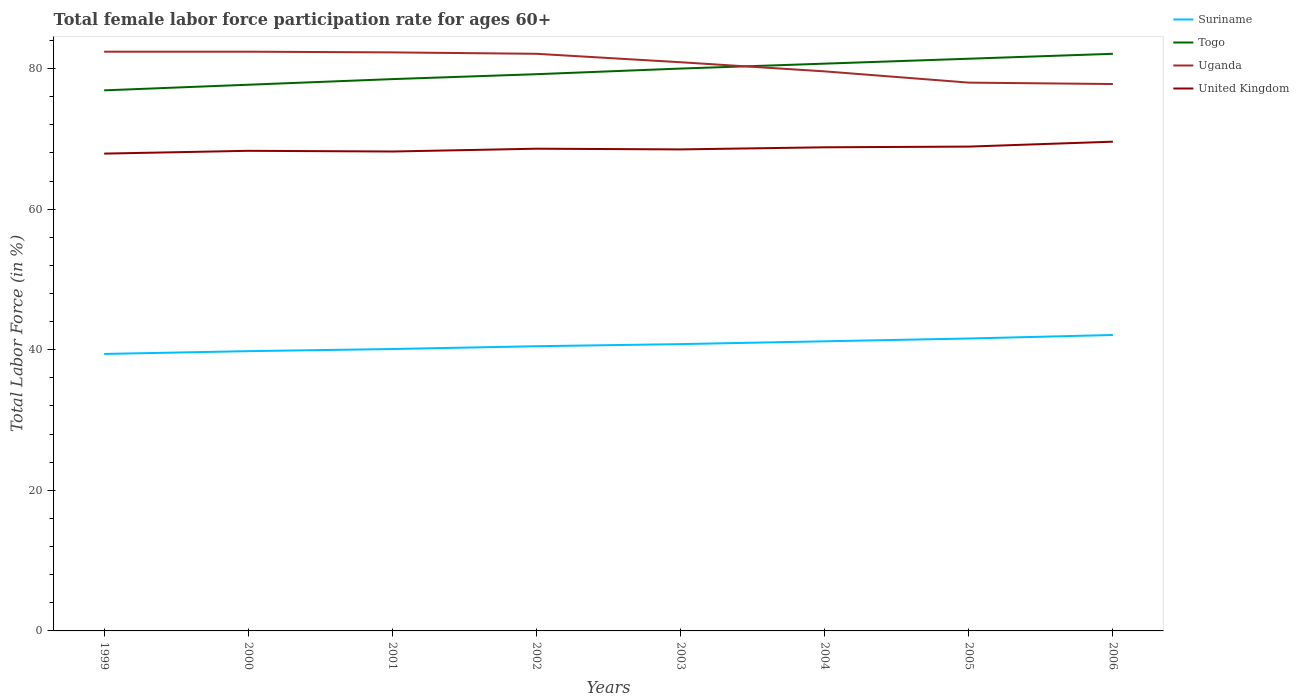How many different coloured lines are there?
Provide a short and direct response. 4. Across all years, what is the maximum female labor force participation rate in Uganda?
Give a very brief answer. 77.8. In which year was the female labor force participation rate in Suriname maximum?
Offer a terse response. 1999. What is the difference between the highest and the second highest female labor force participation rate in United Kingdom?
Keep it short and to the point. 1.7. Is the female labor force participation rate in Togo strictly greater than the female labor force participation rate in Suriname over the years?
Your response must be concise. No. Are the values on the major ticks of Y-axis written in scientific E-notation?
Offer a terse response. No. How are the legend labels stacked?
Offer a very short reply. Vertical. What is the title of the graph?
Offer a very short reply. Total female labor force participation rate for ages 60+. Does "Togo" appear as one of the legend labels in the graph?
Your answer should be compact. Yes. What is the Total Labor Force (in %) in Suriname in 1999?
Provide a succinct answer. 39.4. What is the Total Labor Force (in %) of Togo in 1999?
Provide a succinct answer. 76.9. What is the Total Labor Force (in %) in Uganda in 1999?
Provide a short and direct response. 82.4. What is the Total Labor Force (in %) of United Kingdom in 1999?
Keep it short and to the point. 67.9. What is the Total Labor Force (in %) of Suriname in 2000?
Your answer should be very brief. 39.8. What is the Total Labor Force (in %) in Togo in 2000?
Provide a short and direct response. 77.7. What is the Total Labor Force (in %) in Uganda in 2000?
Provide a short and direct response. 82.4. What is the Total Labor Force (in %) in United Kingdom in 2000?
Ensure brevity in your answer.  68.3. What is the Total Labor Force (in %) in Suriname in 2001?
Your response must be concise. 40.1. What is the Total Labor Force (in %) in Togo in 2001?
Give a very brief answer. 78.5. What is the Total Labor Force (in %) of Uganda in 2001?
Offer a very short reply. 82.3. What is the Total Labor Force (in %) of United Kingdom in 2001?
Offer a very short reply. 68.2. What is the Total Labor Force (in %) in Suriname in 2002?
Your response must be concise. 40.5. What is the Total Labor Force (in %) of Togo in 2002?
Your response must be concise. 79.2. What is the Total Labor Force (in %) in Uganda in 2002?
Provide a succinct answer. 82.1. What is the Total Labor Force (in %) of United Kingdom in 2002?
Give a very brief answer. 68.6. What is the Total Labor Force (in %) of Suriname in 2003?
Offer a terse response. 40.8. What is the Total Labor Force (in %) in Uganda in 2003?
Give a very brief answer. 80.9. What is the Total Labor Force (in %) in United Kingdom in 2003?
Offer a very short reply. 68.5. What is the Total Labor Force (in %) in Suriname in 2004?
Your response must be concise. 41.2. What is the Total Labor Force (in %) in Togo in 2004?
Keep it short and to the point. 80.7. What is the Total Labor Force (in %) of Uganda in 2004?
Give a very brief answer. 79.6. What is the Total Labor Force (in %) in United Kingdom in 2004?
Your answer should be very brief. 68.8. What is the Total Labor Force (in %) in Suriname in 2005?
Your answer should be compact. 41.6. What is the Total Labor Force (in %) in Togo in 2005?
Your response must be concise. 81.4. What is the Total Labor Force (in %) in Uganda in 2005?
Your answer should be very brief. 78. What is the Total Labor Force (in %) of United Kingdom in 2005?
Ensure brevity in your answer.  68.9. What is the Total Labor Force (in %) in Suriname in 2006?
Offer a very short reply. 42.1. What is the Total Labor Force (in %) of Togo in 2006?
Give a very brief answer. 82.1. What is the Total Labor Force (in %) in Uganda in 2006?
Provide a succinct answer. 77.8. What is the Total Labor Force (in %) in United Kingdom in 2006?
Offer a terse response. 69.6. Across all years, what is the maximum Total Labor Force (in %) in Suriname?
Keep it short and to the point. 42.1. Across all years, what is the maximum Total Labor Force (in %) in Togo?
Your answer should be compact. 82.1. Across all years, what is the maximum Total Labor Force (in %) of Uganda?
Make the answer very short. 82.4. Across all years, what is the maximum Total Labor Force (in %) in United Kingdom?
Offer a very short reply. 69.6. Across all years, what is the minimum Total Labor Force (in %) of Suriname?
Provide a short and direct response. 39.4. Across all years, what is the minimum Total Labor Force (in %) of Togo?
Offer a very short reply. 76.9. Across all years, what is the minimum Total Labor Force (in %) of Uganda?
Offer a terse response. 77.8. Across all years, what is the minimum Total Labor Force (in %) of United Kingdom?
Your response must be concise. 67.9. What is the total Total Labor Force (in %) in Suriname in the graph?
Make the answer very short. 325.5. What is the total Total Labor Force (in %) in Togo in the graph?
Provide a short and direct response. 636.5. What is the total Total Labor Force (in %) in Uganda in the graph?
Your response must be concise. 645.5. What is the total Total Labor Force (in %) in United Kingdom in the graph?
Keep it short and to the point. 548.8. What is the difference between the Total Labor Force (in %) in Suriname in 1999 and that in 2000?
Give a very brief answer. -0.4. What is the difference between the Total Labor Force (in %) in Suriname in 1999 and that in 2001?
Offer a terse response. -0.7. What is the difference between the Total Labor Force (in %) of Togo in 1999 and that in 2001?
Provide a succinct answer. -1.6. What is the difference between the Total Labor Force (in %) in Uganda in 1999 and that in 2001?
Offer a very short reply. 0.1. What is the difference between the Total Labor Force (in %) in United Kingdom in 1999 and that in 2001?
Your answer should be compact. -0.3. What is the difference between the Total Labor Force (in %) of Suriname in 1999 and that in 2002?
Provide a short and direct response. -1.1. What is the difference between the Total Labor Force (in %) in Togo in 1999 and that in 2002?
Offer a terse response. -2.3. What is the difference between the Total Labor Force (in %) in Uganda in 1999 and that in 2002?
Your answer should be compact. 0.3. What is the difference between the Total Labor Force (in %) of Suriname in 1999 and that in 2003?
Provide a succinct answer. -1.4. What is the difference between the Total Labor Force (in %) in Uganda in 1999 and that in 2003?
Ensure brevity in your answer.  1.5. What is the difference between the Total Labor Force (in %) in United Kingdom in 1999 and that in 2003?
Your answer should be compact. -0.6. What is the difference between the Total Labor Force (in %) in Uganda in 1999 and that in 2004?
Offer a very short reply. 2.8. What is the difference between the Total Labor Force (in %) in Suriname in 1999 and that in 2005?
Give a very brief answer. -2.2. What is the difference between the Total Labor Force (in %) in Uganda in 1999 and that in 2005?
Offer a very short reply. 4.4. What is the difference between the Total Labor Force (in %) in Suriname in 1999 and that in 2006?
Your response must be concise. -2.7. What is the difference between the Total Labor Force (in %) in United Kingdom in 2000 and that in 2001?
Keep it short and to the point. 0.1. What is the difference between the Total Labor Force (in %) in Uganda in 2000 and that in 2002?
Offer a very short reply. 0.3. What is the difference between the Total Labor Force (in %) in United Kingdom in 2000 and that in 2002?
Make the answer very short. -0.3. What is the difference between the Total Labor Force (in %) in Togo in 2000 and that in 2003?
Offer a terse response. -2.3. What is the difference between the Total Labor Force (in %) of Uganda in 2000 and that in 2003?
Provide a short and direct response. 1.5. What is the difference between the Total Labor Force (in %) of Suriname in 2000 and that in 2004?
Your response must be concise. -1.4. What is the difference between the Total Labor Force (in %) in United Kingdom in 2000 and that in 2004?
Your answer should be very brief. -0.5. What is the difference between the Total Labor Force (in %) in Togo in 2000 and that in 2005?
Make the answer very short. -3.7. What is the difference between the Total Labor Force (in %) in Uganda in 2000 and that in 2005?
Ensure brevity in your answer.  4.4. What is the difference between the Total Labor Force (in %) in United Kingdom in 2000 and that in 2005?
Your response must be concise. -0.6. What is the difference between the Total Labor Force (in %) in Suriname in 2000 and that in 2006?
Make the answer very short. -2.3. What is the difference between the Total Labor Force (in %) in Uganda in 2000 and that in 2006?
Keep it short and to the point. 4.6. What is the difference between the Total Labor Force (in %) in Suriname in 2001 and that in 2002?
Make the answer very short. -0.4. What is the difference between the Total Labor Force (in %) of Togo in 2001 and that in 2002?
Ensure brevity in your answer.  -0.7. What is the difference between the Total Labor Force (in %) in Uganda in 2001 and that in 2002?
Provide a short and direct response. 0.2. What is the difference between the Total Labor Force (in %) of Suriname in 2001 and that in 2003?
Make the answer very short. -0.7. What is the difference between the Total Labor Force (in %) in Uganda in 2001 and that in 2003?
Make the answer very short. 1.4. What is the difference between the Total Labor Force (in %) of United Kingdom in 2001 and that in 2003?
Ensure brevity in your answer.  -0.3. What is the difference between the Total Labor Force (in %) of Togo in 2001 and that in 2005?
Your answer should be compact. -2.9. What is the difference between the Total Labor Force (in %) in Suriname in 2001 and that in 2006?
Provide a short and direct response. -2. What is the difference between the Total Labor Force (in %) of Uganda in 2001 and that in 2006?
Provide a succinct answer. 4.5. What is the difference between the Total Labor Force (in %) in United Kingdom in 2001 and that in 2006?
Offer a terse response. -1.4. What is the difference between the Total Labor Force (in %) in Suriname in 2002 and that in 2003?
Your response must be concise. -0.3. What is the difference between the Total Labor Force (in %) in United Kingdom in 2002 and that in 2003?
Provide a short and direct response. 0.1. What is the difference between the Total Labor Force (in %) of Suriname in 2002 and that in 2004?
Ensure brevity in your answer.  -0.7. What is the difference between the Total Labor Force (in %) of Togo in 2002 and that in 2004?
Ensure brevity in your answer.  -1.5. What is the difference between the Total Labor Force (in %) in Suriname in 2002 and that in 2005?
Make the answer very short. -1.1. What is the difference between the Total Labor Force (in %) of Togo in 2002 and that in 2005?
Keep it short and to the point. -2.2. What is the difference between the Total Labor Force (in %) in Suriname in 2002 and that in 2006?
Give a very brief answer. -1.6. What is the difference between the Total Labor Force (in %) of Togo in 2002 and that in 2006?
Ensure brevity in your answer.  -2.9. What is the difference between the Total Labor Force (in %) in Uganda in 2002 and that in 2006?
Offer a very short reply. 4.3. What is the difference between the Total Labor Force (in %) in Suriname in 2003 and that in 2004?
Your answer should be very brief. -0.4. What is the difference between the Total Labor Force (in %) in Togo in 2003 and that in 2004?
Your answer should be compact. -0.7. What is the difference between the Total Labor Force (in %) of United Kingdom in 2003 and that in 2005?
Provide a succinct answer. -0.4. What is the difference between the Total Labor Force (in %) of Togo in 2003 and that in 2006?
Provide a short and direct response. -2.1. What is the difference between the Total Labor Force (in %) in Uganda in 2003 and that in 2006?
Provide a succinct answer. 3.1. What is the difference between the Total Labor Force (in %) in United Kingdom in 2003 and that in 2006?
Give a very brief answer. -1.1. What is the difference between the Total Labor Force (in %) in Suriname in 2004 and that in 2005?
Provide a short and direct response. -0.4. What is the difference between the Total Labor Force (in %) of Togo in 2004 and that in 2005?
Your answer should be very brief. -0.7. What is the difference between the Total Labor Force (in %) in Uganda in 2004 and that in 2005?
Offer a terse response. 1.6. What is the difference between the Total Labor Force (in %) of Togo in 2004 and that in 2006?
Provide a short and direct response. -1.4. What is the difference between the Total Labor Force (in %) of Suriname in 2005 and that in 2006?
Give a very brief answer. -0.5. What is the difference between the Total Labor Force (in %) of Togo in 2005 and that in 2006?
Ensure brevity in your answer.  -0.7. What is the difference between the Total Labor Force (in %) in Uganda in 2005 and that in 2006?
Provide a short and direct response. 0.2. What is the difference between the Total Labor Force (in %) of Suriname in 1999 and the Total Labor Force (in %) of Togo in 2000?
Make the answer very short. -38.3. What is the difference between the Total Labor Force (in %) in Suriname in 1999 and the Total Labor Force (in %) in Uganda in 2000?
Your response must be concise. -43. What is the difference between the Total Labor Force (in %) of Suriname in 1999 and the Total Labor Force (in %) of United Kingdom in 2000?
Your answer should be very brief. -28.9. What is the difference between the Total Labor Force (in %) of Suriname in 1999 and the Total Labor Force (in %) of Togo in 2001?
Provide a succinct answer. -39.1. What is the difference between the Total Labor Force (in %) of Suriname in 1999 and the Total Labor Force (in %) of Uganda in 2001?
Provide a short and direct response. -42.9. What is the difference between the Total Labor Force (in %) in Suriname in 1999 and the Total Labor Force (in %) in United Kingdom in 2001?
Give a very brief answer. -28.8. What is the difference between the Total Labor Force (in %) in Togo in 1999 and the Total Labor Force (in %) in United Kingdom in 2001?
Give a very brief answer. 8.7. What is the difference between the Total Labor Force (in %) in Uganda in 1999 and the Total Labor Force (in %) in United Kingdom in 2001?
Your answer should be very brief. 14.2. What is the difference between the Total Labor Force (in %) in Suriname in 1999 and the Total Labor Force (in %) in Togo in 2002?
Provide a short and direct response. -39.8. What is the difference between the Total Labor Force (in %) in Suriname in 1999 and the Total Labor Force (in %) in Uganda in 2002?
Provide a short and direct response. -42.7. What is the difference between the Total Labor Force (in %) in Suriname in 1999 and the Total Labor Force (in %) in United Kingdom in 2002?
Your answer should be very brief. -29.2. What is the difference between the Total Labor Force (in %) of Uganda in 1999 and the Total Labor Force (in %) of United Kingdom in 2002?
Provide a succinct answer. 13.8. What is the difference between the Total Labor Force (in %) in Suriname in 1999 and the Total Labor Force (in %) in Togo in 2003?
Provide a short and direct response. -40.6. What is the difference between the Total Labor Force (in %) in Suriname in 1999 and the Total Labor Force (in %) in Uganda in 2003?
Offer a terse response. -41.5. What is the difference between the Total Labor Force (in %) of Suriname in 1999 and the Total Labor Force (in %) of United Kingdom in 2003?
Ensure brevity in your answer.  -29.1. What is the difference between the Total Labor Force (in %) in Togo in 1999 and the Total Labor Force (in %) in Uganda in 2003?
Your answer should be very brief. -4. What is the difference between the Total Labor Force (in %) in Togo in 1999 and the Total Labor Force (in %) in United Kingdom in 2003?
Offer a very short reply. 8.4. What is the difference between the Total Labor Force (in %) in Uganda in 1999 and the Total Labor Force (in %) in United Kingdom in 2003?
Offer a terse response. 13.9. What is the difference between the Total Labor Force (in %) of Suriname in 1999 and the Total Labor Force (in %) of Togo in 2004?
Ensure brevity in your answer.  -41.3. What is the difference between the Total Labor Force (in %) in Suriname in 1999 and the Total Labor Force (in %) in Uganda in 2004?
Your response must be concise. -40.2. What is the difference between the Total Labor Force (in %) of Suriname in 1999 and the Total Labor Force (in %) of United Kingdom in 2004?
Provide a short and direct response. -29.4. What is the difference between the Total Labor Force (in %) of Togo in 1999 and the Total Labor Force (in %) of Uganda in 2004?
Provide a short and direct response. -2.7. What is the difference between the Total Labor Force (in %) of Togo in 1999 and the Total Labor Force (in %) of United Kingdom in 2004?
Ensure brevity in your answer.  8.1. What is the difference between the Total Labor Force (in %) of Uganda in 1999 and the Total Labor Force (in %) of United Kingdom in 2004?
Provide a succinct answer. 13.6. What is the difference between the Total Labor Force (in %) in Suriname in 1999 and the Total Labor Force (in %) in Togo in 2005?
Your answer should be very brief. -42. What is the difference between the Total Labor Force (in %) of Suriname in 1999 and the Total Labor Force (in %) of Uganda in 2005?
Your response must be concise. -38.6. What is the difference between the Total Labor Force (in %) in Suriname in 1999 and the Total Labor Force (in %) in United Kingdom in 2005?
Provide a short and direct response. -29.5. What is the difference between the Total Labor Force (in %) of Togo in 1999 and the Total Labor Force (in %) of Uganda in 2005?
Ensure brevity in your answer.  -1.1. What is the difference between the Total Labor Force (in %) of Togo in 1999 and the Total Labor Force (in %) of United Kingdom in 2005?
Ensure brevity in your answer.  8. What is the difference between the Total Labor Force (in %) in Suriname in 1999 and the Total Labor Force (in %) in Togo in 2006?
Make the answer very short. -42.7. What is the difference between the Total Labor Force (in %) in Suriname in 1999 and the Total Labor Force (in %) in Uganda in 2006?
Keep it short and to the point. -38.4. What is the difference between the Total Labor Force (in %) of Suriname in 1999 and the Total Labor Force (in %) of United Kingdom in 2006?
Offer a terse response. -30.2. What is the difference between the Total Labor Force (in %) in Togo in 1999 and the Total Labor Force (in %) in United Kingdom in 2006?
Provide a succinct answer. 7.3. What is the difference between the Total Labor Force (in %) in Uganda in 1999 and the Total Labor Force (in %) in United Kingdom in 2006?
Your response must be concise. 12.8. What is the difference between the Total Labor Force (in %) of Suriname in 2000 and the Total Labor Force (in %) of Togo in 2001?
Offer a very short reply. -38.7. What is the difference between the Total Labor Force (in %) in Suriname in 2000 and the Total Labor Force (in %) in Uganda in 2001?
Your answer should be very brief. -42.5. What is the difference between the Total Labor Force (in %) in Suriname in 2000 and the Total Labor Force (in %) in United Kingdom in 2001?
Your answer should be very brief. -28.4. What is the difference between the Total Labor Force (in %) in Suriname in 2000 and the Total Labor Force (in %) in Togo in 2002?
Offer a very short reply. -39.4. What is the difference between the Total Labor Force (in %) of Suriname in 2000 and the Total Labor Force (in %) of Uganda in 2002?
Give a very brief answer. -42.3. What is the difference between the Total Labor Force (in %) of Suriname in 2000 and the Total Labor Force (in %) of United Kingdom in 2002?
Offer a terse response. -28.8. What is the difference between the Total Labor Force (in %) in Togo in 2000 and the Total Labor Force (in %) in Uganda in 2002?
Provide a short and direct response. -4.4. What is the difference between the Total Labor Force (in %) of Togo in 2000 and the Total Labor Force (in %) of United Kingdom in 2002?
Make the answer very short. 9.1. What is the difference between the Total Labor Force (in %) of Suriname in 2000 and the Total Labor Force (in %) of Togo in 2003?
Offer a very short reply. -40.2. What is the difference between the Total Labor Force (in %) in Suriname in 2000 and the Total Labor Force (in %) in Uganda in 2003?
Offer a very short reply. -41.1. What is the difference between the Total Labor Force (in %) in Suriname in 2000 and the Total Labor Force (in %) in United Kingdom in 2003?
Offer a terse response. -28.7. What is the difference between the Total Labor Force (in %) in Togo in 2000 and the Total Labor Force (in %) in United Kingdom in 2003?
Provide a short and direct response. 9.2. What is the difference between the Total Labor Force (in %) of Suriname in 2000 and the Total Labor Force (in %) of Togo in 2004?
Your answer should be very brief. -40.9. What is the difference between the Total Labor Force (in %) of Suriname in 2000 and the Total Labor Force (in %) of Uganda in 2004?
Your response must be concise. -39.8. What is the difference between the Total Labor Force (in %) of Togo in 2000 and the Total Labor Force (in %) of United Kingdom in 2004?
Your response must be concise. 8.9. What is the difference between the Total Labor Force (in %) in Uganda in 2000 and the Total Labor Force (in %) in United Kingdom in 2004?
Your answer should be compact. 13.6. What is the difference between the Total Labor Force (in %) in Suriname in 2000 and the Total Labor Force (in %) in Togo in 2005?
Your answer should be compact. -41.6. What is the difference between the Total Labor Force (in %) in Suriname in 2000 and the Total Labor Force (in %) in Uganda in 2005?
Provide a short and direct response. -38.2. What is the difference between the Total Labor Force (in %) in Suriname in 2000 and the Total Labor Force (in %) in United Kingdom in 2005?
Provide a succinct answer. -29.1. What is the difference between the Total Labor Force (in %) in Togo in 2000 and the Total Labor Force (in %) in Uganda in 2005?
Offer a terse response. -0.3. What is the difference between the Total Labor Force (in %) of Uganda in 2000 and the Total Labor Force (in %) of United Kingdom in 2005?
Your answer should be compact. 13.5. What is the difference between the Total Labor Force (in %) of Suriname in 2000 and the Total Labor Force (in %) of Togo in 2006?
Your answer should be compact. -42.3. What is the difference between the Total Labor Force (in %) in Suriname in 2000 and the Total Labor Force (in %) in Uganda in 2006?
Keep it short and to the point. -38. What is the difference between the Total Labor Force (in %) in Suriname in 2000 and the Total Labor Force (in %) in United Kingdom in 2006?
Your answer should be very brief. -29.8. What is the difference between the Total Labor Force (in %) of Togo in 2000 and the Total Labor Force (in %) of Uganda in 2006?
Offer a very short reply. -0.1. What is the difference between the Total Labor Force (in %) of Togo in 2000 and the Total Labor Force (in %) of United Kingdom in 2006?
Give a very brief answer. 8.1. What is the difference between the Total Labor Force (in %) in Uganda in 2000 and the Total Labor Force (in %) in United Kingdom in 2006?
Ensure brevity in your answer.  12.8. What is the difference between the Total Labor Force (in %) of Suriname in 2001 and the Total Labor Force (in %) of Togo in 2002?
Ensure brevity in your answer.  -39.1. What is the difference between the Total Labor Force (in %) in Suriname in 2001 and the Total Labor Force (in %) in Uganda in 2002?
Make the answer very short. -42. What is the difference between the Total Labor Force (in %) in Suriname in 2001 and the Total Labor Force (in %) in United Kingdom in 2002?
Your response must be concise. -28.5. What is the difference between the Total Labor Force (in %) in Togo in 2001 and the Total Labor Force (in %) in Uganda in 2002?
Ensure brevity in your answer.  -3.6. What is the difference between the Total Labor Force (in %) in Togo in 2001 and the Total Labor Force (in %) in United Kingdom in 2002?
Provide a succinct answer. 9.9. What is the difference between the Total Labor Force (in %) in Uganda in 2001 and the Total Labor Force (in %) in United Kingdom in 2002?
Make the answer very short. 13.7. What is the difference between the Total Labor Force (in %) of Suriname in 2001 and the Total Labor Force (in %) of Togo in 2003?
Your answer should be compact. -39.9. What is the difference between the Total Labor Force (in %) in Suriname in 2001 and the Total Labor Force (in %) in Uganda in 2003?
Make the answer very short. -40.8. What is the difference between the Total Labor Force (in %) of Suriname in 2001 and the Total Labor Force (in %) of United Kingdom in 2003?
Ensure brevity in your answer.  -28.4. What is the difference between the Total Labor Force (in %) in Togo in 2001 and the Total Labor Force (in %) in United Kingdom in 2003?
Your answer should be compact. 10. What is the difference between the Total Labor Force (in %) in Uganda in 2001 and the Total Labor Force (in %) in United Kingdom in 2003?
Your answer should be very brief. 13.8. What is the difference between the Total Labor Force (in %) in Suriname in 2001 and the Total Labor Force (in %) in Togo in 2004?
Offer a terse response. -40.6. What is the difference between the Total Labor Force (in %) in Suriname in 2001 and the Total Labor Force (in %) in Uganda in 2004?
Your response must be concise. -39.5. What is the difference between the Total Labor Force (in %) of Suriname in 2001 and the Total Labor Force (in %) of United Kingdom in 2004?
Your answer should be compact. -28.7. What is the difference between the Total Labor Force (in %) in Togo in 2001 and the Total Labor Force (in %) in Uganda in 2004?
Offer a terse response. -1.1. What is the difference between the Total Labor Force (in %) in Togo in 2001 and the Total Labor Force (in %) in United Kingdom in 2004?
Provide a short and direct response. 9.7. What is the difference between the Total Labor Force (in %) of Suriname in 2001 and the Total Labor Force (in %) of Togo in 2005?
Provide a succinct answer. -41.3. What is the difference between the Total Labor Force (in %) of Suriname in 2001 and the Total Labor Force (in %) of Uganda in 2005?
Give a very brief answer. -37.9. What is the difference between the Total Labor Force (in %) of Suriname in 2001 and the Total Labor Force (in %) of United Kingdom in 2005?
Ensure brevity in your answer.  -28.8. What is the difference between the Total Labor Force (in %) in Suriname in 2001 and the Total Labor Force (in %) in Togo in 2006?
Provide a short and direct response. -42. What is the difference between the Total Labor Force (in %) in Suriname in 2001 and the Total Labor Force (in %) in Uganda in 2006?
Offer a very short reply. -37.7. What is the difference between the Total Labor Force (in %) of Suriname in 2001 and the Total Labor Force (in %) of United Kingdom in 2006?
Provide a succinct answer. -29.5. What is the difference between the Total Labor Force (in %) in Togo in 2001 and the Total Labor Force (in %) in Uganda in 2006?
Provide a succinct answer. 0.7. What is the difference between the Total Labor Force (in %) in Suriname in 2002 and the Total Labor Force (in %) in Togo in 2003?
Offer a terse response. -39.5. What is the difference between the Total Labor Force (in %) of Suriname in 2002 and the Total Labor Force (in %) of Uganda in 2003?
Give a very brief answer. -40.4. What is the difference between the Total Labor Force (in %) of Suriname in 2002 and the Total Labor Force (in %) of Togo in 2004?
Offer a very short reply. -40.2. What is the difference between the Total Labor Force (in %) of Suriname in 2002 and the Total Labor Force (in %) of Uganda in 2004?
Make the answer very short. -39.1. What is the difference between the Total Labor Force (in %) of Suriname in 2002 and the Total Labor Force (in %) of United Kingdom in 2004?
Provide a short and direct response. -28.3. What is the difference between the Total Labor Force (in %) of Togo in 2002 and the Total Labor Force (in %) of Uganda in 2004?
Offer a terse response. -0.4. What is the difference between the Total Labor Force (in %) in Togo in 2002 and the Total Labor Force (in %) in United Kingdom in 2004?
Give a very brief answer. 10.4. What is the difference between the Total Labor Force (in %) of Suriname in 2002 and the Total Labor Force (in %) of Togo in 2005?
Your answer should be very brief. -40.9. What is the difference between the Total Labor Force (in %) of Suriname in 2002 and the Total Labor Force (in %) of Uganda in 2005?
Keep it short and to the point. -37.5. What is the difference between the Total Labor Force (in %) of Suriname in 2002 and the Total Labor Force (in %) of United Kingdom in 2005?
Keep it short and to the point. -28.4. What is the difference between the Total Labor Force (in %) in Togo in 2002 and the Total Labor Force (in %) in United Kingdom in 2005?
Offer a terse response. 10.3. What is the difference between the Total Labor Force (in %) in Uganda in 2002 and the Total Labor Force (in %) in United Kingdom in 2005?
Your answer should be very brief. 13.2. What is the difference between the Total Labor Force (in %) in Suriname in 2002 and the Total Labor Force (in %) in Togo in 2006?
Offer a terse response. -41.6. What is the difference between the Total Labor Force (in %) in Suriname in 2002 and the Total Labor Force (in %) in Uganda in 2006?
Make the answer very short. -37.3. What is the difference between the Total Labor Force (in %) in Suriname in 2002 and the Total Labor Force (in %) in United Kingdom in 2006?
Offer a very short reply. -29.1. What is the difference between the Total Labor Force (in %) of Togo in 2002 and the Total Labor Force (in %) of United Kingdom in 2006?
Your response must be concise. 9.6. What is the difference between the Total Labor Force (in %) in Uganda in 2002 and the Total Labor Force (in %) in United Kingdom in 2006?
Make the answer very short. 12.5. What is the difference between the Total Labor Force (in %) in Suriname in 2003 and the Total Labor Force (in %) in Togo in 2004?
Ensure brevity in your answer.  -39.9. What is the difference between the Total Labor Force (in %) in Suriname in 2003 and the Total Labor Force (in %) in Uganda in 2004?
Give a very brief answer. -38.8. What is the difference between the Total Labor Force (in %) in Togo in 2003 and the Total Labor Force (in %) in Uganda in 2004?
Make the answer very short. 0.4. What is the difference between the Total Labor Force (in %) in Togo in 2003 and the Total Labor Force (in %) in United Kingdom in 2004?
Your answer should be very brief. 11.2. What is the difference between the Total Labor Force (in %) in Uganda in 2003 and the Total Labor Force (in %) in United Kingdom in 2004?
Your answer should be very brief. 12.1. What is the difference between the Total Labor Force (in %) in Suriname in 2003 and the Total Labor Force (in %) in Togo in 2005?
Provide a succinct answer. -40.6. What is the difference between the Total Labor Force (in %) of Suriname in 2003 and the Total Labor Force (in %) of Uganda in 2005?
Your answer should be compact. -37.2. What is the difference between the Total Labor Force (in %) in Suriname in 2003 and the Total Labor Force (in %) in United Kingdom in 2005?
Ensure brevity in your answer.  -28.1. What is the difference between the Total Labor Force (in %) in Togo in 2003 and the Total Labor Force (in %) in Uganda in 2005?
Your answer should be compact. 2. What is the difference between the Total Labor Force (in %) in Togo in 2003 and the Total Labor Force (in %) in United Kingdom in 2005?
Make the answer very short. 11.1. What is the difference between the Total Labor Force (in %) in Uganda in 2003 and the Total Labor Force (in %) in United Kingdom in 2005?
Provide a succinct answer. 12. What is the difference between the Total Labor Force (in %) in Suriname in 2003 and the Total Labor Force (in %) in Togo in 2006?
Offer a terse response. -41.3. What is the difference between the Total Labor Force (in %) in Suriname in 2003 and the Total Labor Force (in %) in Uganda in 2006?
Give a very brief answer. -37. What is the difference between the Total Labor Force (in %) of Suriname in 2003 and the Total Labor Force (in %) of United Kingdom in 2006?
Offer a terse response. -28.8. What is the difference between the Total Labor Force (in %) in Togo in 2003 and the Total Labor Force (in %) in United Kingdom in 2006?
Make the answer very short. 10.4. What is the difference between the Total Labor Force (in %) in Uganda in 2003 and the Total Labor Force (in %) in United Kingdom in 2006?
Offer a terse response. 11.3. What is the difference between the Total Labor Force (in %) of Suriname in 2004 and the Total Labor Force (in %) of Togo in 2005?
Ensure brevity in your answer.  -40.2. What is the difference between the Total Labor Force (in %) of Suriname in 2004 and the Total Labor Force (in %) of Uganda in 2005?
Provide a short and direct response. -36.8. What is the difference between the Total Labor Force (in %) in Suriname in 2004 and the Total Labor Force (in %) in United Kingdom in 2005?
Offer a very short reply. -27.7. What is the difference between the Total Labor Force (in %) of Uganda in 2004 and the Total Labor Force (in %) of United Kingdom in 2005?
Your answer should be very brief. 10.7. What is the difference between the Total Labor Force (in %) of Suriname in 2004 and the Total Labor Force (in %) of Togo in 2006?
Your answer should be very brief. -40.9. What is the difference between the Total Labor Force (in %) in Suriname in 2004 and the Total Labor Force (in %) in Uganda in 2006?
Give a very brief answer. -36.6. What is the difference between the Total Labor Force (in %) in Suriname in 2004 and the Total Labor Force (in %) in United Kingdom in 2006?
Your answer should be very brief. -28.4. What is the difference between the Total Labor Force (in %) of Togo in 2004 and the Total Labor Force (in %) of United Kingdom in 2006?
Your answer should be compact. 11.1. What is the difference between the Total Labor Force (in %) in Uganda in 2004 and the Total Labor Force (in %) in United Kingdom in 2006?
Your answer should be compact. 10. What is the difference between the Total Labor Force (in %) of Suriname in 2005 and the Total Labor Force (in %) of Togo in 2006?
Provide a succinct answer. -40.5. What is the difference between the Total Labor Force (in %) of Suriname in 2005 and the Total Labor Force (in %) of Uganda in 2006?
Provide a succinct answer. -36.2. What is the difference between the Total Labor Force (in %) in Togo in 2005 and the Total Labor Force (in %) in United Kingdom in 2006?
Make the answer very short. 11.8. What is the difference between the Total Labor Force (in %) of Uganda in 2005 and the Total Labor Force (in %) of United Kingdom in 2006?
Make the answer very short. 8.4. What is the average Total Labor Force (in %) of Suriname per year?
Your answer should be compact. 40.69. What is the average Total Labor Force (in %) in Togo per year?
Offer a terse response. 79.56. What is the average Total Labor Force (in %) of Uganda per year?
Your answer should be very brief. 80.69. What is the average Total Labor Force (in %) of United Kingdom per year?
Ensure brevity in your answer.  68.6. In the year 1999, what is the difference between the Total Labor Force (in %) in Suriname and Total Labor Force (in %) in Togo?
Provide a short and direct response. -37.5. In the year 1999, what is the difference between the Total Labor Force (in %) in Suriname and Total Labor Force (in %) in Uganda?
Keep it short and to the point. -43. In the year 1999, what is the difference between the Total Labor Force (in %) of Suriname and Total Labor Force (in %) of United Kingdom?
Your response must be concise. -28.5. In the year 2000, what is the difference between the Total Labor Force (in %) of Suriname and Total Labor Force (in %) of Togo?
Provide a succinct answer. -37.9. In the year 2000, what is the difference between the Total Labor Force (in %) in Suriname and Total Labor Force (in %) in Uganda?
Ensure brevity in your answer.  -42.6. In the year 2000, what is the difference between the Total Labor Force (in %) of Suriname and Total Labor Force (in %) of United Kingdom?
Provide a succinct answer. -28.5. In the year 2000, what is the difference between the Total Labor Force (in %) in Togo and Total Labor Force (in %) in Uganda?
Keep it short and to the point. -4.7. In the year 2001, what is the difference between the Total Labor Force (in %) in Suriname and Total Labor Force (in %) in Togo?
Offer a very short reply. -38.4. In the year 2001, what is the difference between the Total Labor Force (in %) in Suriname and Total Labor Force (in %) in Uganda?
Offer a very short reply. -42.2. In the year 2001, what is the difference between the Total Labor Force (in %) in Suriname and Total Labor Force (in %) in United Kingdom?
Your response must be concise. -28.1. In the year 2001, what is the difference between the Total Labor Force (in %) of Togo and Total Labor Force (in %) of Uganda?
Your response must be concise. -3.8. In the year 2001, what is the difference between the Total Labor Force (in %) of Uganda and Total Labor Force (in %) of United Kingdom?
Offer a very short reply. 14.1. In the year 2002, what is the difference between the Total Labor Force (in %) in Suriname and Total Labor Force (in %) in Togo?
Your answer should be compact. -38.7. In the year 2002, what is the difference between the Total Labor Force (in %) of Suriname and Total Labor Force (in %) of Uganda?
Provide a short and direct response. -41.6. In the year 2002, what is the difference between the Total Labor Force (in %) of Suriname and Total Labor Force (in %) of United Kingdom?
Make the answer very short. -28.1. In the year 2002, what is the difference between the Total Labor Force (in %) of Togo and Total Labor Force (in %) of Uganda?
Ensure brevity in your answer.  -2.9. In the year 2002, what is the difference between the Total Labor Force (in %) in Togo and Total Labor Force (in %) in United Kingdom?
Your answer should be very brief. 10.6. In the year 2002, what is the difference between the Total Labor Force (in %) in Uganda and Total Labor Force (in %) in United Kingdom?
Make the answer very short. 13.5. In the year 2003, what is the difference between the Total Labor Force (in %) of Suriname and Total Labor Force (in %) of Togo?
Your response must be concise. -39.2. In the year 2003, what is the difference between the Total Labor Force (in %) of Suriname and Total Labor Force (in %) of Uganda?
Your response must be concise. -40.1. In the year 2003, what is the difference between the Total Labor Force (in %) of Suriname and Total Labor Force (in %) of United Kingdom?
Your answer should be very brief. -27.7. In the year 2003, what is the difference between the Total Labor Force (in %) of Togo and Total Labor Force (in %) of United Kingdom?
Offer a very short reply. 11.5. In the year 2003, what is the difference between the Total Labor Force (in %) in Uganda and Total Labor Force (in %) in United Kingdom?
Give a very brief answer. 12.4. In the year 2004, what is the difference between the Total Labor Force (in %) in Suriname and Total Labor Force (in %) in Togo?
Your answer should be compact. -39.5. In the year 2004, what is the difference between the Total Labor Force (in %) of Suriname and Total Labor Force (in %) of Uganda?
Offer a terse response. -38.4. In the year 2004, what is the difference between the Total Labor Force (in %) in Suriname and Total Labor Force (in %) in United Kingdom?
Your response must be concise. -27.6. In the year 2004, what is the difference between the Total Labor Force (in %) of Togo and Total Labor Force (in %) of United Kingdom?
Your answer should be compact. 11.9. In the year 2005, what is the difference between the Total Labor Force (in %) of Suriname and Total Labor Force (in %) of Togo?
Offer a terse response. -39.8. In the year 2005, what is the difference between the Total Labor Force (in %) of Suriname and Total Labor Force (in %) of Uganda?
Make the answer very short. -36.4. In the year 2005, what is the difference between the Total Labor Force (in %) in Suriname and Total Labor Force (in %) in United Kingdom?
Offer a terse response. -27.3. In the year 2005, what is the difference between the Total Labor Force (in %) of Togo and Total Labor Force (in %) of United Kingdom?
Provide a succinct answer. 12.5. In the year 2006, what is the difference between the Total Labor Force (in %) in Suriname and Total Labor Force (in %) in Togo?
Provide a succinct answer. -40. In the year 2006, what is the difference between the Total Labor Force (in %) in Suriname and Total Labor Force (in %) in Uganda?
Offer a terse response. -35.7. In the year 2006, what is the difference between the Total Labor Force (in %) in Suriname and Total Labor Force (in %) in United Kingdom?
Your answer should be compact. -27.5. What is the ratio of the Total Labor Force (in %) in Uganda in 1999 to that in 2000?
Offer a terse response. 1. What is the ratio of the Total Labor Force (in %) in United Kingdom in 1999 to that in 2000?
Offer a terse response. 0.99. What is the ratio of the Total Labor Force (in %) of Suriname in 1999 to that in 2001?
Your answer should be compact. 0.98. What is the ratio of the Total Labor Force (in %) of Togo in 1999 to that in 2001?
Provide a short and direct response. 0.98. What is the ratio of the Total Labor Force (in %) of United Kingdom in 1999 to that in 2001?
Offer a terse response. 1. What is the ratio of the Total Labor Force (in %) in Suriname in 1999 to that in 2002?
Ensure brevity in your answer.  0.97. What is the ratio of the Total Labor Force (in %) of Suriname in 1999 to that in 2003?
Provide a short and direct response. 0.97. What is the ratio of the Total Labor Force (in %) in Togo in 1999 to that in 2003?
Offer a very short reply. 0.96. What is the ratio of the Total Labor Force (in %) of Uganda in 1999 to that in 2003?
Make the answer very short. 1.02. What is the ratio of the Total Labor Force (in %) of United Kingdom in 1999 to that in 2003?
Keep it short and to the point. 0.99. What is the ratio of the Total Labor Force (in %) in Suriname in 1999 to that in 2004?
Your response must be concise. 0.96. What is the ratio of the Total Labor Force (in %) in Togo in 1999 to that in 2004?
Ensure brevity in your answer.  0.95. What is the ratio of the Total Labor Force (in %) in Uganda in 1999 to that in 2004?
Keep it short and to the point. 1.04. What is the ratio of the Total Labor Force (in %) in United Kingdom in 1999 to that in 2004?
Your response must be concise. 0.99. What is the ratio of the Total Labor Force (in %) of Suriname in 1999 to that in 2005?
Your answer should be compact. 0.95. What is the ratio of the Total Labor Force (in %) in Togo in 1999 to that in 2005?
Offer a very short reply. 0.94. What is the ratio of the Total Labor Force (in %) of Uganda in 1999 to that in 2005?
Your answer should be very brief. 1.06. What is the ratio of the Total Labor Force (in %) in United Kingdom in 1999 to that in 2005?
Ensure brevity in your answer.  0.99. What is the ratio of the Total Labor Force (in %) of Suriname in 1999 to that in 2006?
Offer a terse response. 0.94. What is the ratio of the Total Labor Force (in %) of Togo in 1999 to that in 2006?
Ensure brevity in your answer.  0.94. What is the ratio of the Total Labor Force (in %) in Uganda in 1999 to that in 2006?
Keep it short and to the point. 1.06. What is the ratio of the Total Labor Force (in %) in United Kingdom in 1999 to that in 2006?
Offer a terse response. 0.98. What is the ratio of the Total Labor Force (in %) of United Kingdom in 2000 to that in 2001?
Offer a terse response. 1. What is the ratio of the Total Labor Force (in %) of Suriname in 2000 to that in 2002?
Give a very brief answer. 0.98. What is the ratio of the Total Labor Force (in %) in Togo in 2000 to that in 2002?
Provide a succinct answer. 0.98. What is the ratio of the Total Labor Force (in %) of Uganda in 2000 to that in 2002?
Keep it short and to the point. 1. What is the ratio of the Total Labor Force (in %) in Suriname in 2000 to that in 2003?
Give a very brief answer. 0.98. What is the ratio of the Total Labor Force (in %) in Togo in 2000 to that in 2003?
Provide a short and direct response. 0.97. What is the ratio of the Total Labor Force (in %) in Uganda in 2000 to that in 2003?
Offer a terse response. 1.02. What is the ratio of the Total Labor Force (in %) of United Kingdom in 2000 to that in 2003?
Offer a very short reply. 1. What is the ratio of the Total Labor Force (in %) in Togo in 2000 to that in 2004?
Provide a short and direct response. 0.96. What is the ratio of the Total Labor Force (in %) of Uganda in 2000 to that in 2004?
Provide a succinct answer. 1.04. What is the ratio of the Total Labor Force (in %) of United Kingdom in 2000 to that in 2004?
Your response must be concise. 0.99. What is the ratio of the Total Labor Force (in %) in Suriname in 2000 to that in 2005?
Provide a succinct answer. 0.96. What is the ratio of the Total Labor Force (in %) of Togo in 2000 to that in 2005?
Provide a short and direct response. 0.95. What is the ratio of the Total Labor Force (in %) in Uganda in 2000 to that in 2005?
Your answer should be compact. 1.06. What is the ratio of the Total Labor Force (in %) of United Kingdom in 2000 to that in 2005?
Give a very brief answer. 0.99. What is the ratio of the Total Labor Force (in %) of Suriname in 2000 to that in 2006?
Provide a succinct answer. 0.95. What is the ratio of the Total Labor Force (in %) of Togo in 2000 to that in 2006?
Your answer should be very brief. 0.95. What is the ratio of the Total Labor Force (in %) of Uganda in 2000 to that in 2006?
Your answer should be very brief. 1.06. What is the ratio of the Total Labor Force (in %) in United Kingdom in 2000 to that in 2006?
Offer a terse response. 0.98. What is the ratio of the Total Labor Force (in %) in Suriname in 2001 to that in 2003?
Provide a succinct answer. 0.98. What is the ratio of the Total Labor Force (in %) of Togo in 2001 to that in 2003?
Make the answer very short. 0.98. What is the ratio of the Total Labor Force (in %) in Uganda in 2001 to that in 2003?
Offer a terse response. 1.02. What is the ratio of the Total Labor Force (in %) in United Kingdom in 2001 to that in 2003?
Provide a short and direct response. 1. What is the ratio of the Total Labor Force (in %) in Suriname in 2001 to that in 2004?
Ensure brevity in your answer.  0.97. What is the ratio of the Total Labor Force (in %) of Togo in 2001 to that in 2004?
Offer a terse response. 0.97. What is the ratio of the Total Labor Force (in %) in Uganda in 2001 to that in 2004?
Provide a succinct answer. 1.03. What is the ratio of the Total Labor Force (in %) in Suriname in 2001 to that in 2005?
Keep it short and to the point. 0.96. What is the ratio of the Total Labor Force (in %) of Togo in 2001 to that in 2005?
Keep it short and to the point. 0.96. What is the ratio of the Total Labor Force (in %) in Uganda in 2001 to that in 2005?
Your answer should be very brief. 1.06. What is the ratio of the Total Labor Force (in %) of United Kingdom in 2001 to that in 2005?
Give a very brief answer. 0.99. What is the ratio of the Total Labor Force (in %) of Suriname in 2001 to that in 2006?
Give a very brief answer. 0.95. What is the ratio of the Total Labor Force (in %) of Togo in 2001 to that in 2006?
Give a very brief answer. 0.96. What is the ratio of the Total Labor Force (in %) of Uganda in 2001 to that in 2006?
Keep it short and to the point. 1.06. What is the ratio of the Total Labor Force (in %) in United Kingdom in 2001 to that in 2006?
Provide a short and direct response. 0.98. What is the ratio of the Total Labor Force (in %) in Uganda in 2002 to that in 2003?
Your answer should be very brief. 1.01. What is the ratio of the Total Labor Force (in %) in United Kingdom in 2002 to that in 2003?
Your answer should be compact. 1. What is the ratio of the Total Labor Force (in %) in Suriname in 2002 to that in 2004?
Your answer should be very brief. 0.98. What is the ratio of the Total Labor Force (in %) of Togo in 2002 to that in 2004?
Offer a terse response. 0.98. What is the ratio of the Total Labor Force (in %) of Uganda in 2002 to that in 2004?
Your answer should be compact. 1.03. What is the ratio of the Total Labor Force (in %) of United Kingdom in 2002 to that in 2004?
Your answer should be compact. 1. What is the ratio of the Total Labor Force (in %) of Suriname in 2002 to that in 2005?
Offer a very short reply. 0.97. What is the ratio of the Total Labor Force (in %) in Uganda in 2002 to that in 2005?
Offer a terse response. 1.05. What is the ratio of the Total Labor Force (in %) in United Kingdom in 2002 to that in 2005?
Give a very brief answer. 1. What is the ratio of the Total Labor Force (in %) of Togo in 2002 to that in 2006?
Make the answer very short. 0.96. What is the ratio of the Total Labor Force (in %) in Uganda in 2002 to that in 2006?
Offer a terse response. 1.06. What is the ratio of the Total Labor Force (in %) of United Kingdom in 2002 to that in 2006?
Your response must be concise. 0.99. What is the ratio of the Total Labor Force (in %) of Suriname in 2003 to that in 2004?
Your answer should be very brief. 0.99. What is the ratio of the Total Labor Force (in %) of Togo in 2003 to that in 2004?
Provide a succinct answer. 0.99. What is the ratio of the Total Labor Force (in %) of Uganda in 2003 to that in 2004?
Give a very brief answer. 1.02. What is the ratio of the Total Labor Force (in %) of United Kingdom in 2003 to that in 2004?
Your answer should be very brief. 1. What is the ratio of the Total Labor Force (in %) in Suriname in 2003 to that in 2005?
Offer a very short reply. 0.98. What is the ratio of the Total Labor Force (in %) in Togo in 2003 to that in 2005?
Keep it short and to the point. 0.98. What is the ratio of the Total Labor Force (in %) of Uganda in 2003 to that in 2005?
Provide a short and direct response. 1.04. What is the ratio of the Total Labor Force (in %) of United Kingdom in 2003 to that in 2005?
Offer a terse response. 0.99. What is the ratio of the Total Labor Force (in %) in Suriname in 2003 to that in 2006?
Provide a succinct answer. 0.97. What is the ratio of the Total Labor Force (in %) in Togo in 2003 to that in 2006?
Offer a terse response. 0.97. What is the ratio of the Total Labor Force (in %) of Uganda in 2003 to that in 2006?
Give a very brief answer. 1.04. What is the ratio of the Total Labor Force (in %) in United Kingdom in 2003 to that in 2006?
Your answer should be very brief. 0.98. What is the ratio of the Total Labor Force (in %) of Togo in 2004 to that in 2005?
Keep it short and to the point. 0.99. What is the ratio of the Total Labor Force (in %) in Uganda in 2004 to that in 2005?
Your response must be concise. 1.02. What is the ratio of the Total Labor Force (in %) of Suriname in 2004 to that in 2006?
Keep it short and to the point. 0.98. What is the ratio of the Total Labor Force (in %) of Togo in 2004 to that in 2006?
Give a very brief answer. 0.98. What is the ratio of the Total Labor Force (in %) of Uganda in 2004 to that in 2006?
Offer a very short reply. 1.02. What is the ratio of the Total Labor Force (in %) of United Kingdom in 2004 to that in 2006?
Make the answer very short. 0.99. What is the ratio of the Total Labor Force (in %) in Togo in 2005 to that in 2006?
Provide a short and direct response. 0.99. What is the ratio of the Total Labor Force (in %) in United Kingdom in 2005 to that in 2006?
Provide a succinct answer. 0.99. What is the difference between the highest and the second highest Total Labor Force (in %) in Suriname?
Offer a terse response. 0.5. What is the difference between the highest and the second highest Total Labor Force (in %) in United Kingdom?
Make the answer very short. 0.7. What is the difference between the highest and the lowest Total Labor Force (in %) of Togo?
Your answer should be compact. 5.2. 